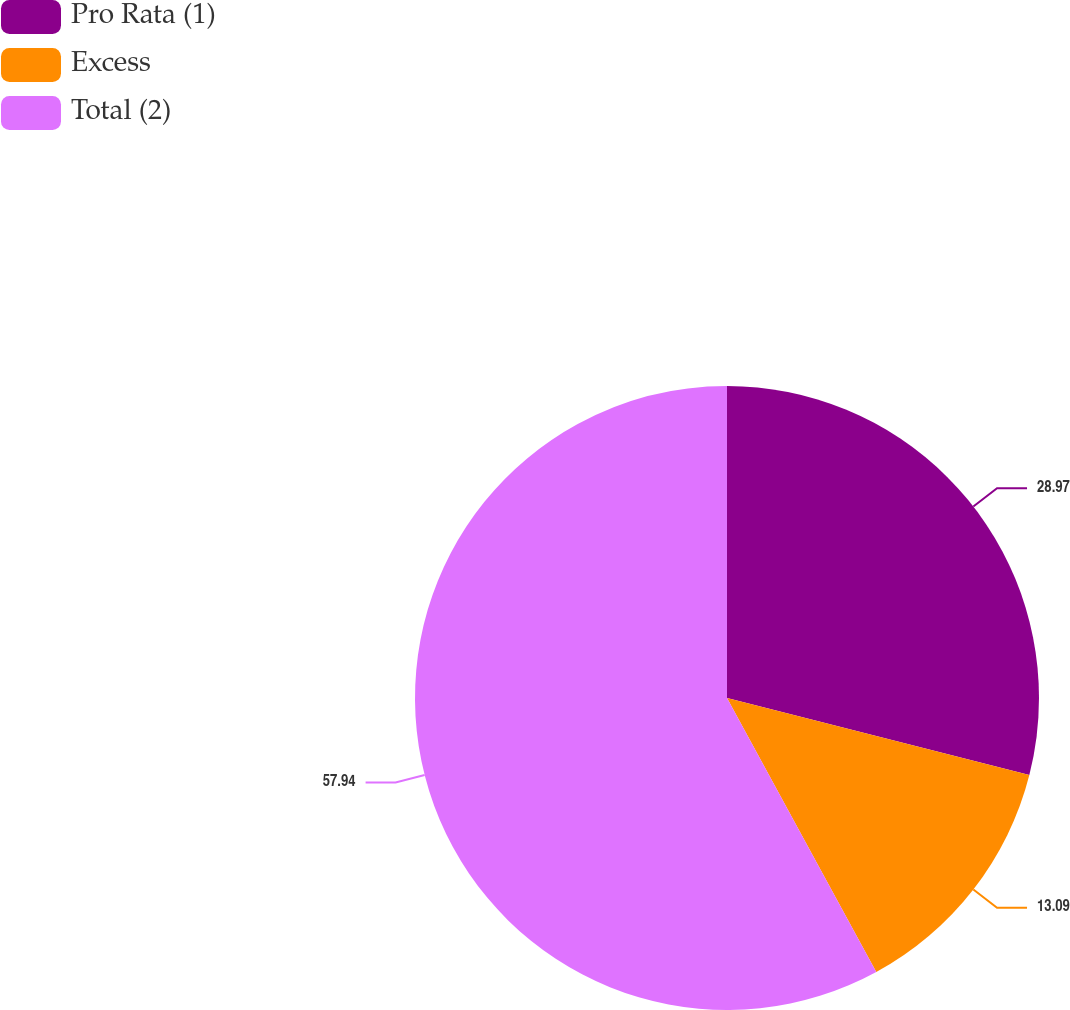<chart> <loc_0><loc_0><loc_500><loc_500><pie_chart><fcel>Pro Rata (1)<fcel>Excess<fcel>Total (2)<nl><fcel>28.97%<fcel>13.09%<fcel>57.94%<nl></chart> 